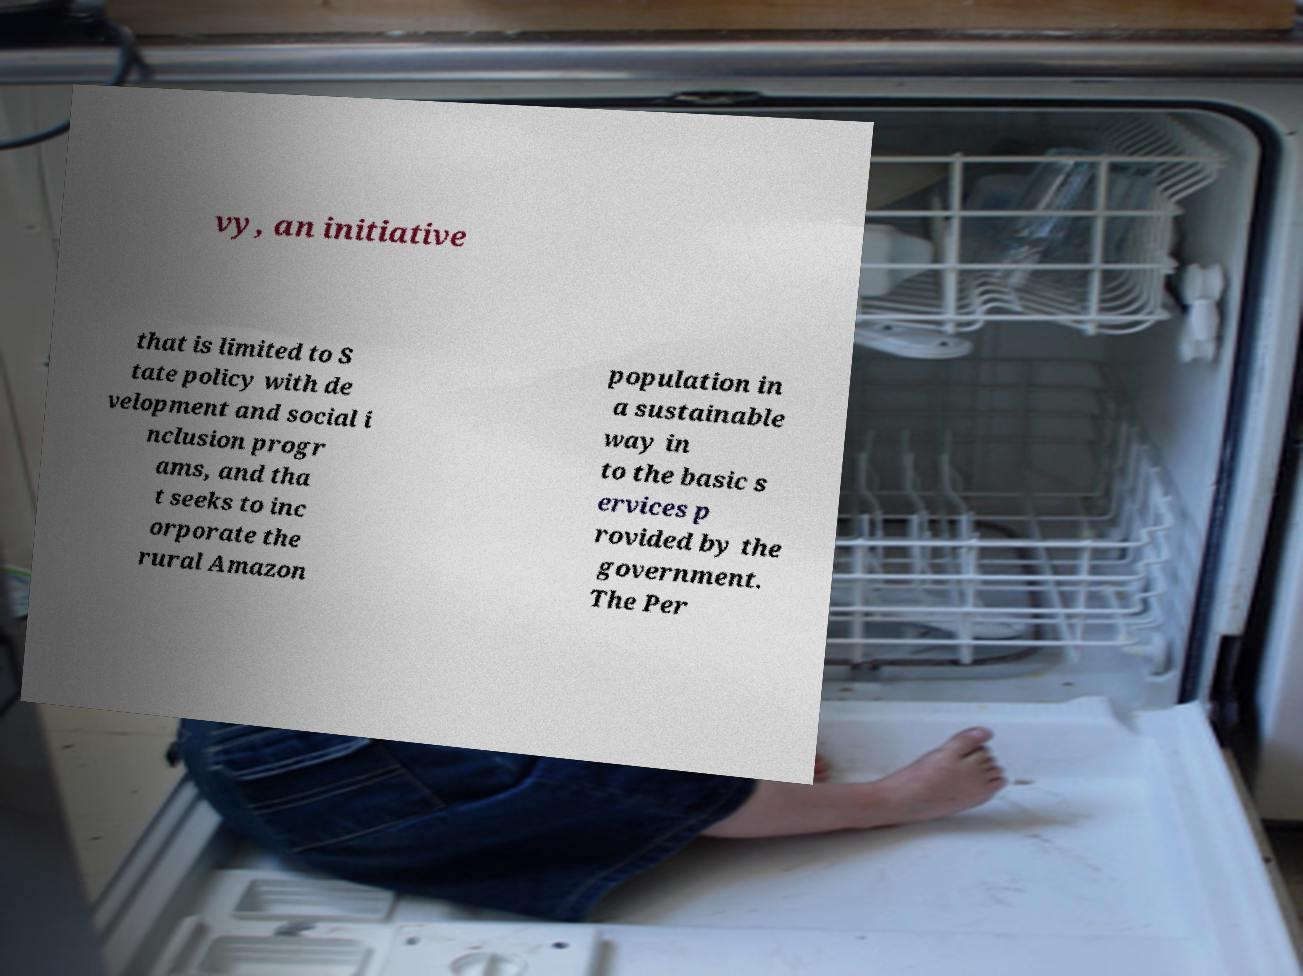Could you extract and type out the text from this image? vy, an initiative that is limited to S tate policy with de velopment and social i nclusion progr ams, and tha t seeks to inc orporate the rural Amazon population in a sustainable way in to the basic s ervices p rovided by the government. The Per 